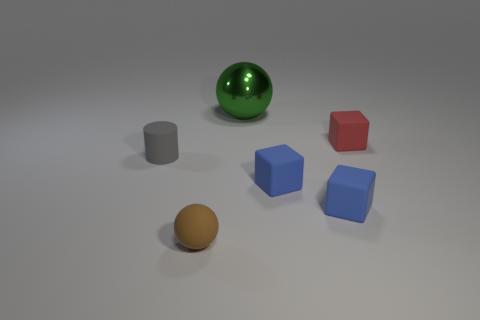There is a matte sphere that is the same size as the gray thing; what color is it?
Offer a terse response. Brown. There is a sphere that is to the left of the ball behind the ball in front of the large green metallic ball; what is it made of?
Provide a succinct answer. Rubber. There is a matte ball; does it have the same color as the sphere that is behind the brown ball?
Offer a very short reply. No. What number of objects are either small matte things that are on the right side of the small brown matte sphere or objects on the left side of the tiny brown matte object?
Ensure brevity in your answer.  4. What is the shape of the tiny thing that is behind the object left of the rubber sphere?
Your response must be concise. Cube. Is there a object that has the same material as the brown sphere?
Provide a succinct answer. Yes. What is the color of the tiny thing that is the same shape as the large shiny thing?
Offer a very short reply. Brown. Is the number of large green metallic things that are on the left side of the large green sphere less than the number of small things on the left side of the red rubber object?
Offer a very short reply. Yes. What number of other objects are there of the same shape as the red thing?
Make the answer very short. 2. Are there fewer small blue rubber objects behind the green ball than tiny red balls?
Keep it short and to the point. No. 